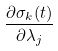<formula> <loc_0><loc_0><loc_500><loc_500>\frac { \partial \sigma _ { k } ( t ) } { \partial \lambda _ { j } }</formula> 